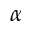<formula> <loc_0><loc_0><loc_500><loc_500>\alpha</formula> 